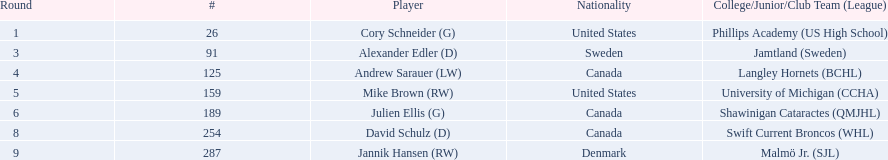Which individuals with canadian nationality are players? Andrew Sarauer (LW), Julien Ellis (G), David Schulz (D). Out of them, who were part of langley hornets? Andrew Sarauer (LW). 